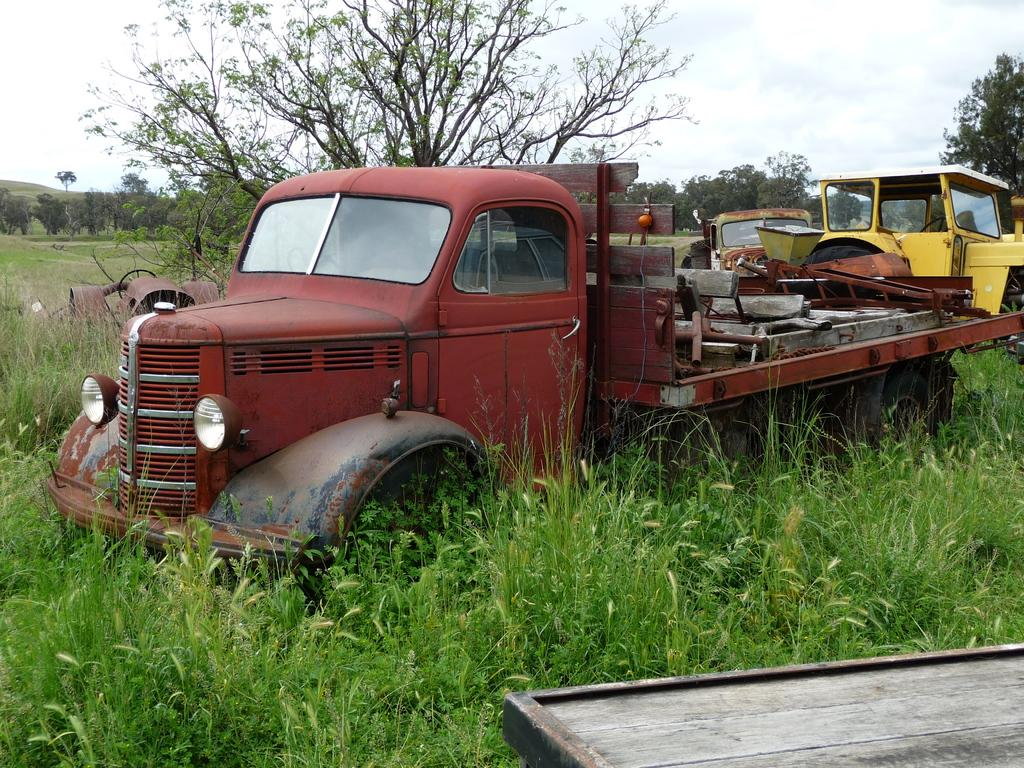What type of vehicles can be seen in the image? There are scrapped vehicles in the image. Where are the vehicles located? The vehicles are kept on a land. What type of vegetation is present in the image? There are a lot of plants and trees in the image. What type of thrill can be experienced while riding on the scrapped vehicles in the image? There is no indication in the image that the scrapped vehicles are being ridden or used for any activity, so it's not possible to determine if there is any thrill involved. 